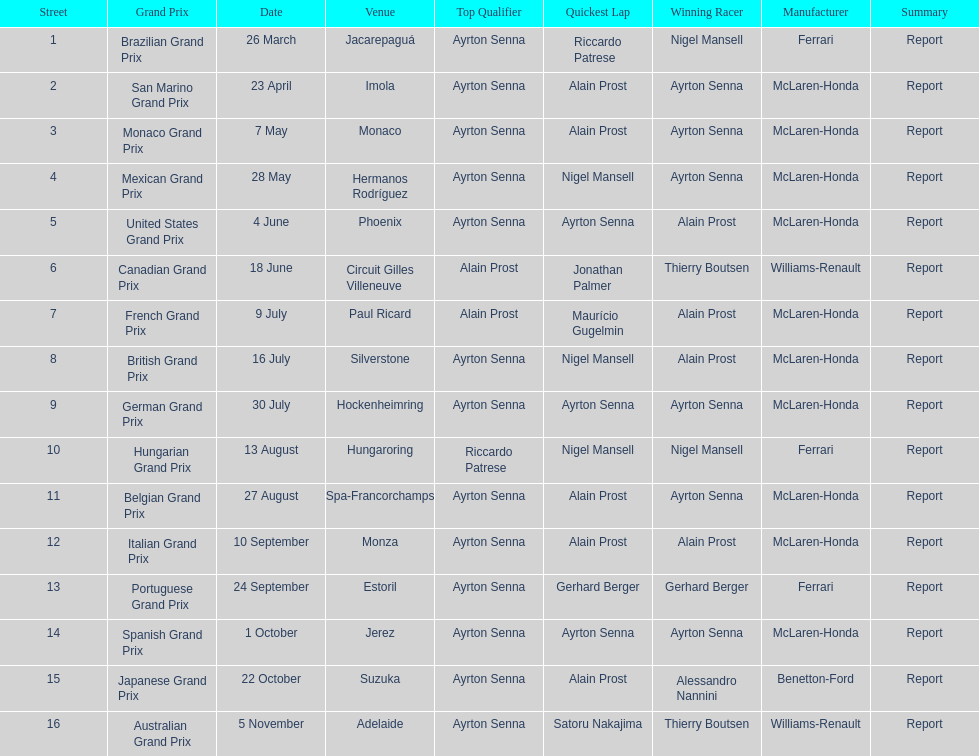Prost won the drivers title, who was his teammate? Ayrton Senna. 